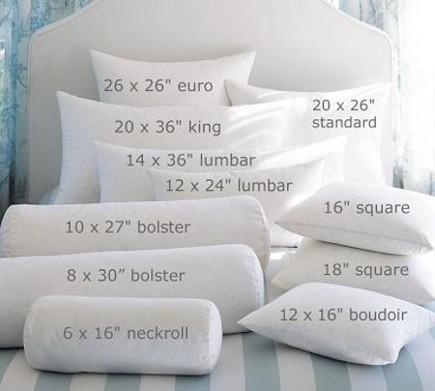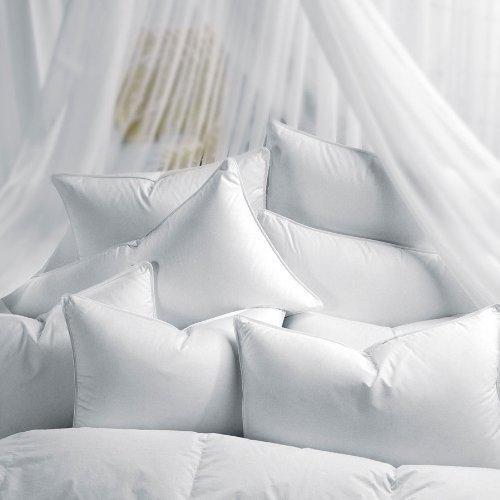The first image is the image on the left, the second image is the image on the right. For the images shown, is this caption "Every photo features less than four white pillows all displayed inside a home." true? Answer yes or no. No. 